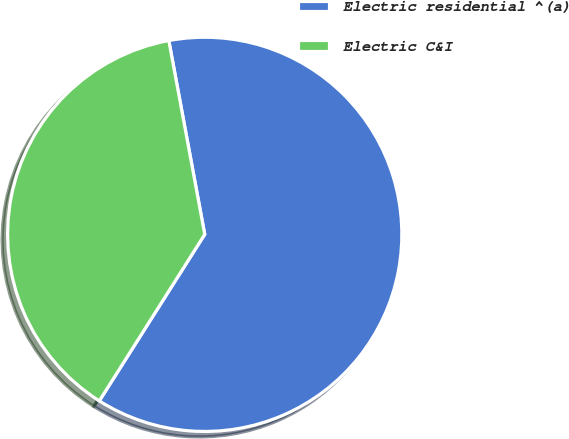Convert chart. <chart><loc_0><loc_0><loc_500><loc_500><pie_chart><fcel>Electric residential ^(a)<fcel>Electric C&I<nl><fcel>61.9%<fcel>38.1%<nl></chart> 